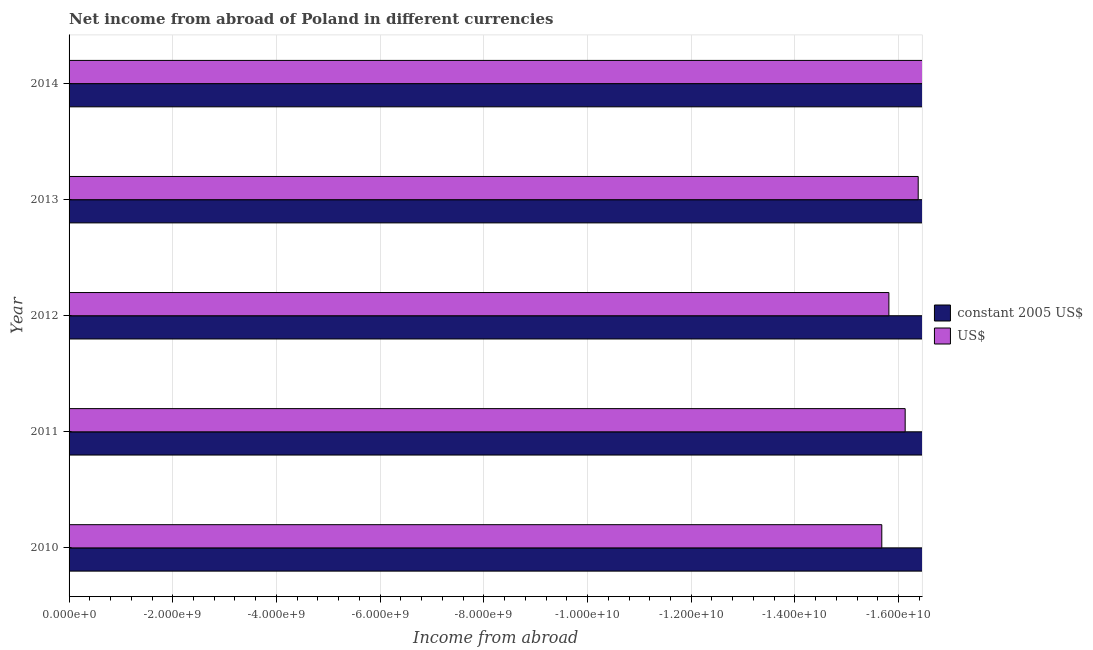Are the number of bars per tick equal to the number of legend labels?
Your answer should be compact. No. How many bars are there on the 3rd tick from the top?
Provide a short and direct response. 0. What is the label of the 1st group of bars from the top?
Your response must be concise. 2014. What is the income from abroad in constant 2005 us$ in 2011?
Your answer should be very brief. 0. What is the difference between the income from abroad in constant 2005 us$ in 2013 and the income from abroad in us$ in 2010?
Offer a very short reply. 0. In how many years, is the income from abroad in constant 2005 us$ greater than the average income from abroad in constant 2005 us$ taken over all years?
Keep it short and to the point. 0. How many bars are there?
Offer a very short reply. 0. Are all the bars in the graph horizontal?
Make the answer very short. Yes. Are the values on the major ticks of X-axis written in scientific E-notation?
Offer a very short reply. Yes. Where does the legend appear in the graph?
Your answer should be very brief. Center right. How many legend labels are there?
Provide a short and direct response. 2. What is the title of the graph?
Ensure brevity in your answer.  Net income from abroad of Poland in different currencies. What is the label or title of the X-axis?
Give a very brief answer. Income from abroad. What is the Income from abroad of constant 2005 US$ in 2010?
Keep it short and to the point. 0. What is the Income from abroad of US$ in 2011?
Provide a succinct answer. 0. What is the Income from abroad in constant 2005 US$ in 2014?
Offer a very short reply. 0. What is the total Income from abroad of constant 2005 US$ in the graph?
Your answer should be compact. 0. 